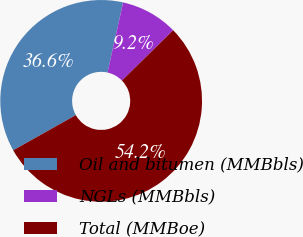Convert chart. <chart><loc_0><loc_0><loc_500><loc_500><pie_chart><fcel>Oil and bitumen (MMBbls)<fcel>NGLs (MMBbls)<fcel>Total (MMBoe)<nl><fcel>36.64%<fcel>9.16%<fcel>54.2%<nl></chart> 